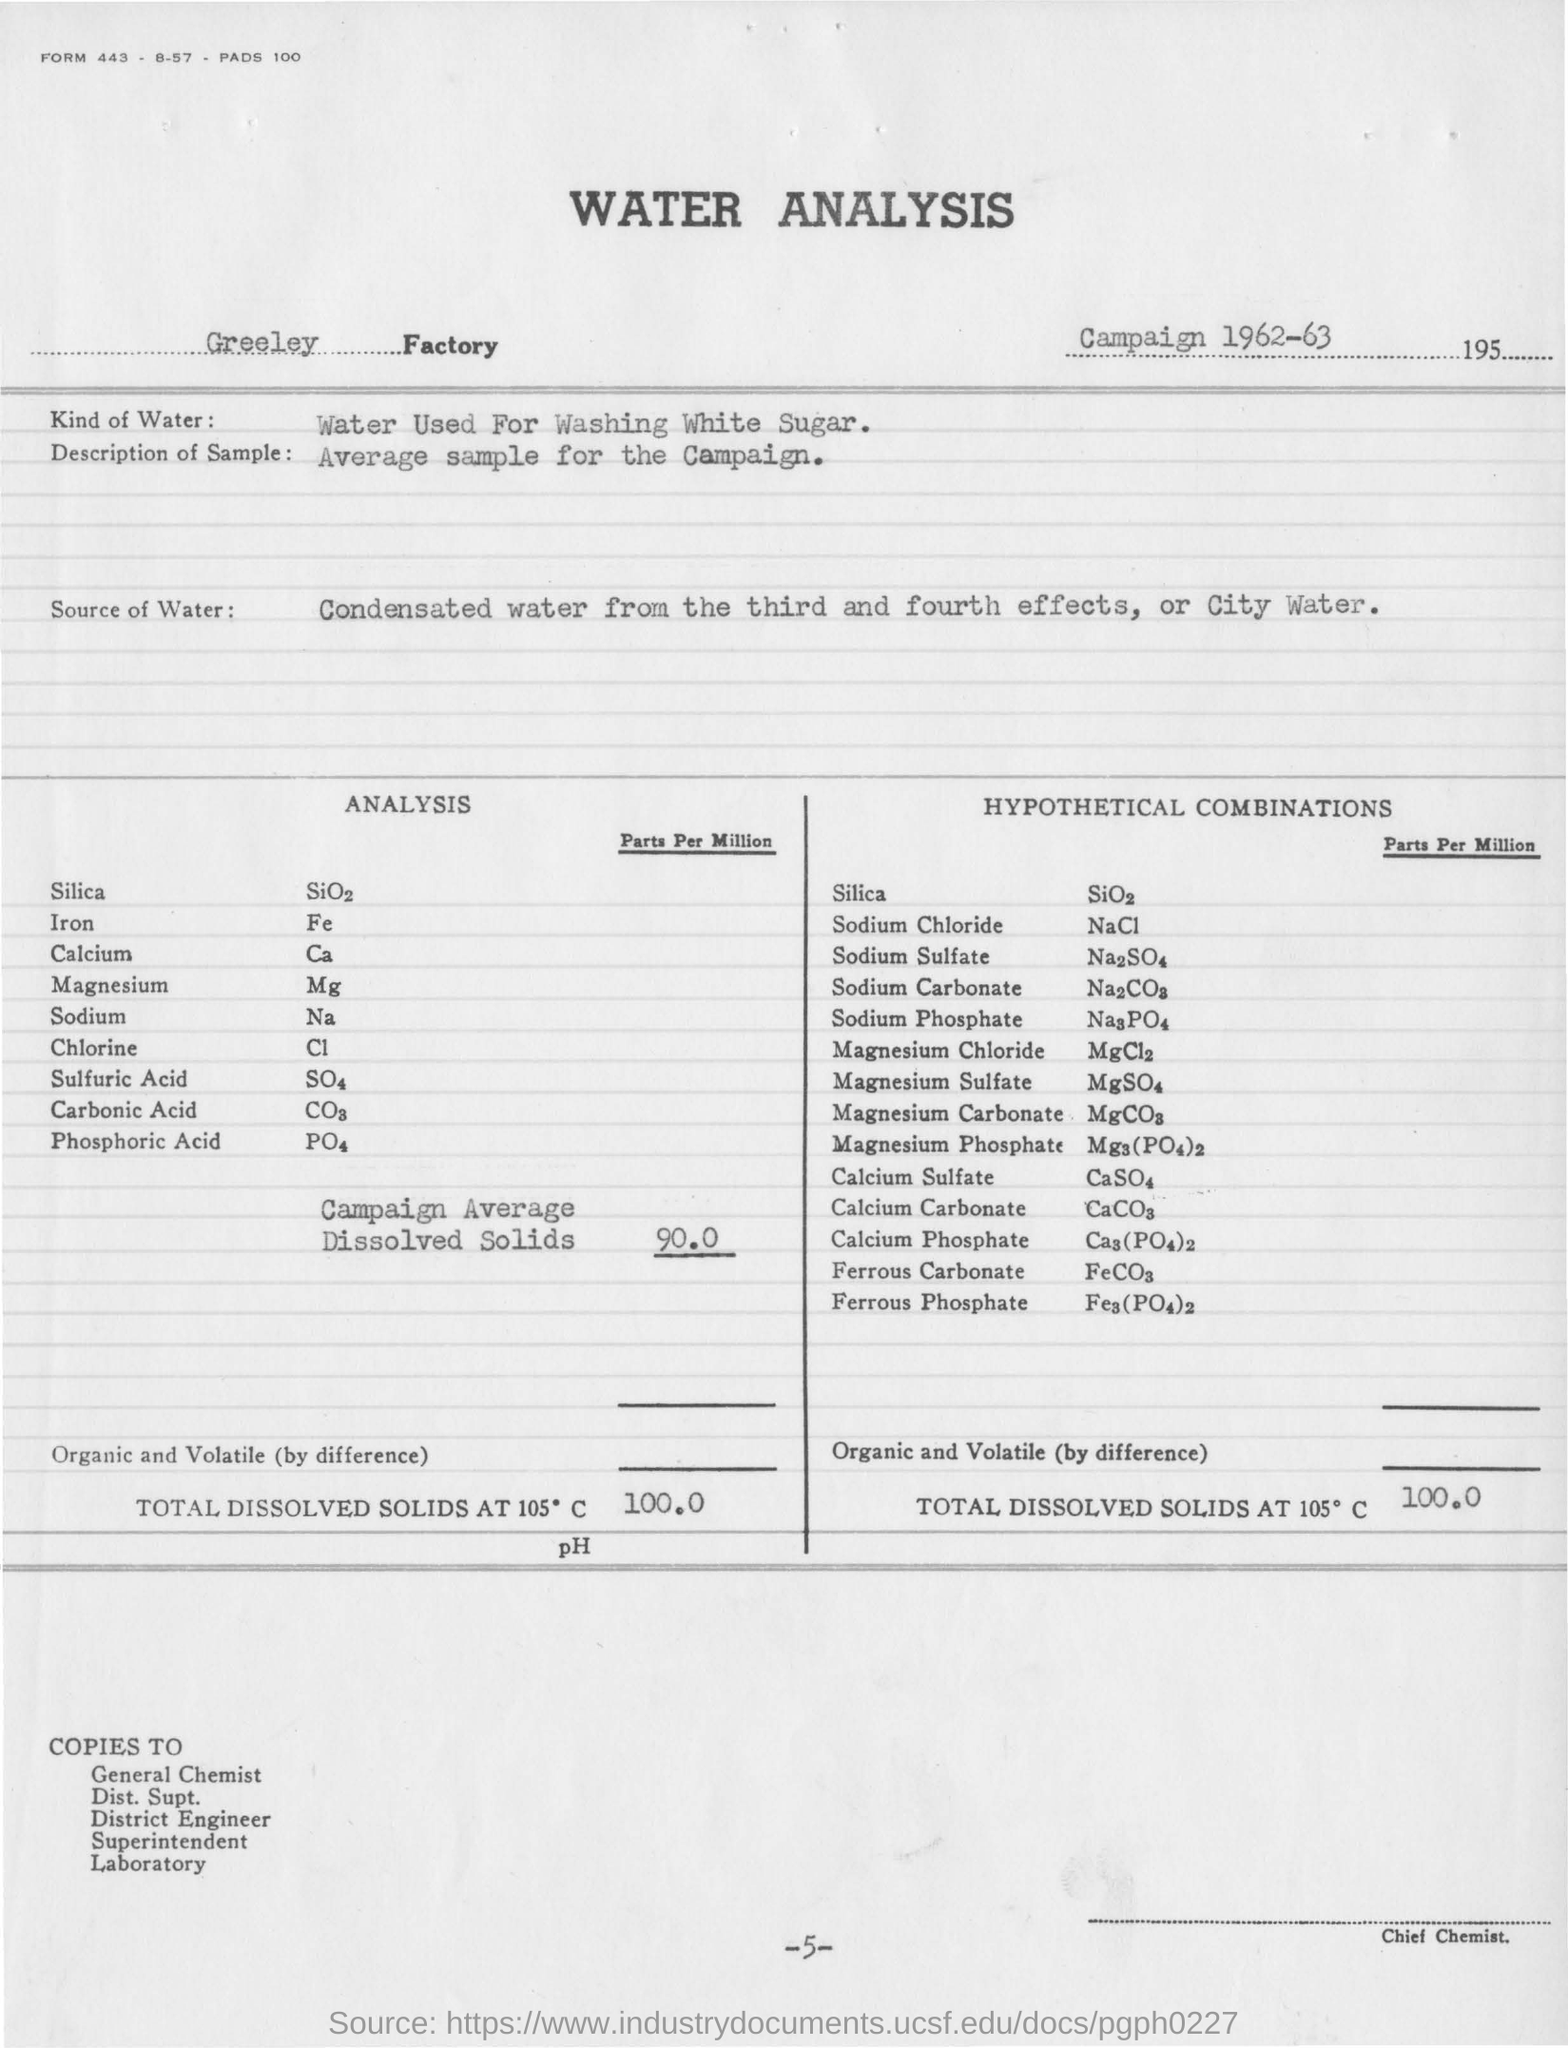Indicate a few pertinent items in this graphic. The source of water for the water analysis in this experiment is either condensed water from the third and fourth effects, or city water. The campaign average dissolved solids is 90.0 parts per million. The campaign for water analysis was conducted in 1962-63. 